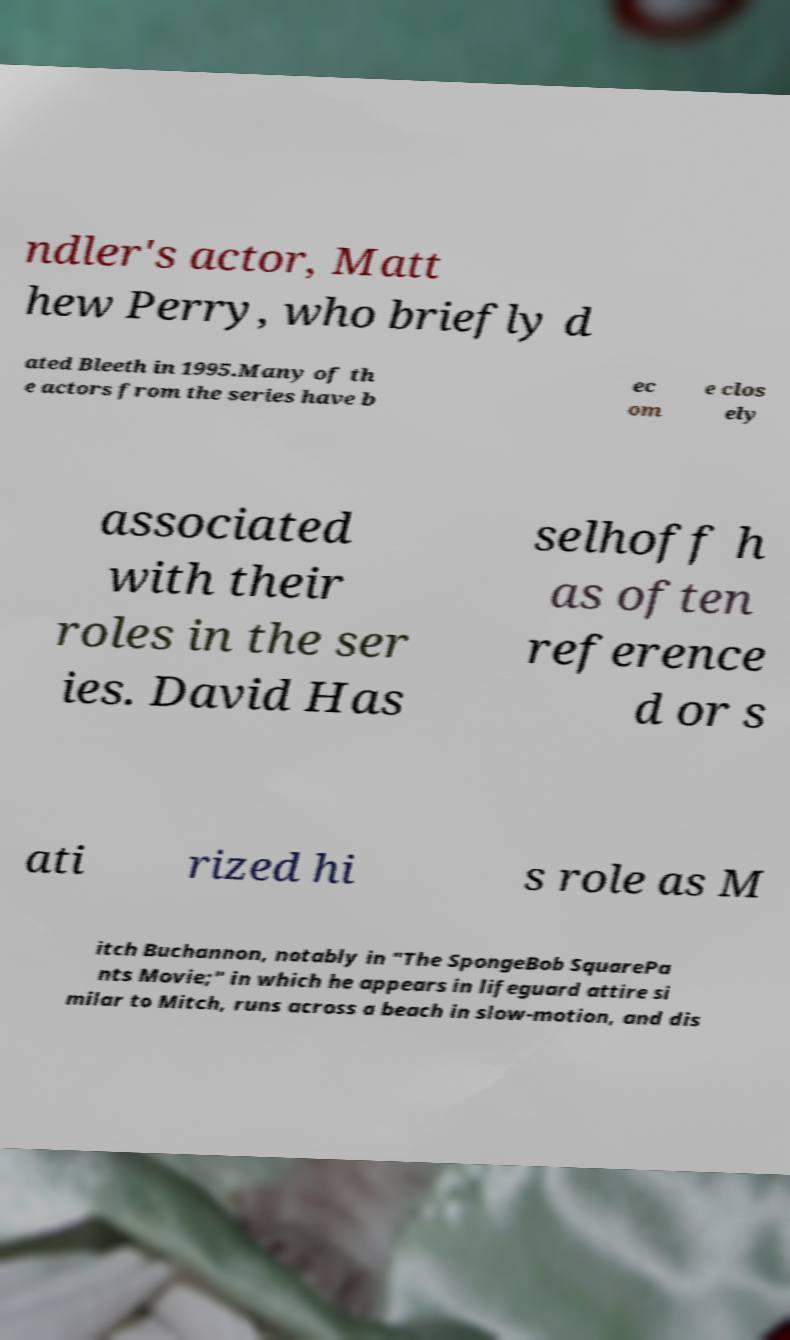Can you accurately transcribe the text from the provided image for me? ndler's actor, Matt hew Perry, who briefly d ated Bleeth in 1995.Many of th e actors from the series have b ec om e clos ely associated with their roles in the ser ies. David Has selhoff h as often reference d or s ati rized hi s role as M itch Buchannon, notably in "The SpongeBob SquarePa nts Movie;" in which he appears in lifeguard attire si milar to Mitch, runs across a beach in slow-motion, and dis 